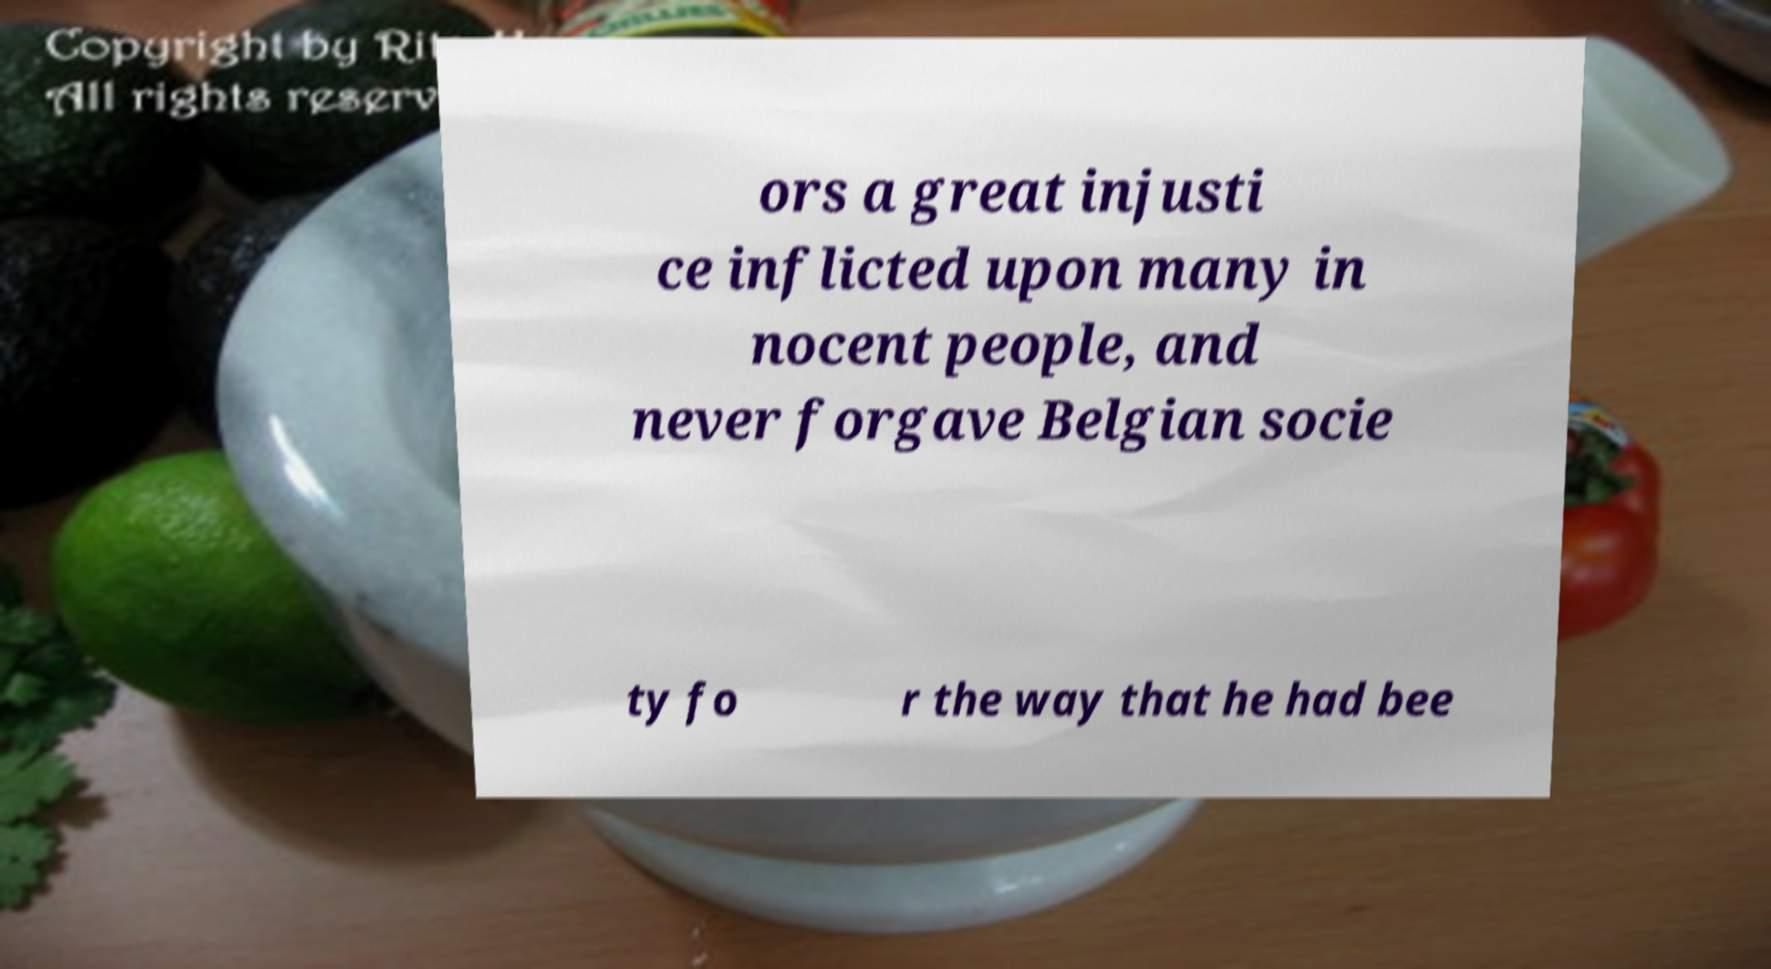Could you assist in decoding the text presented in this image and type it out clearly? ors a great injusti ce inflicted upon many in nocent people, and never forgave Belgian socie ty fo r the way that he had bee 